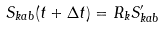<formula> <loc_0><loc_0><loc_500><loc_500>S _ { k a b } ( t + \Delta t ) = R _ { k } S ^ { \prime } _ { k a b }</formula> 